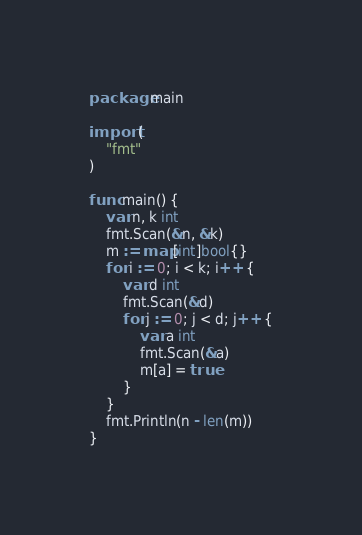<code> <loc_0><loc_0><loc_500><loc_500><_Go_>package main

import (
	"fmt"
)

func main() {
	var n, k int
	fmt.Scan(&n, &k)
	m := map[int]bool{}
	for i := 0; i < k; i++ {
		var d int
		fmt.Scan(&d)
		for j := 0; j < d; j++ {
			var a int
			fmt.Scan(&a)
			m[a] = true
		}
	}
	fmt.Println(n - len(m))
}
</code> 